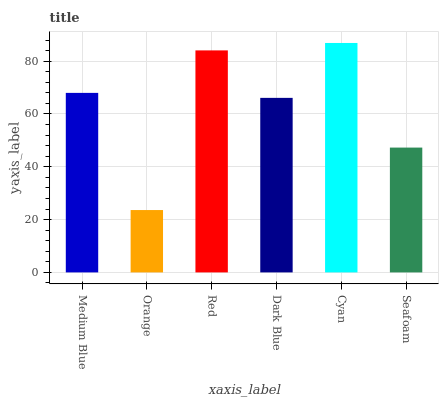Is Orange the minimum?
Answer yes or no. Yes. Is Cyan the maximum?
Answer yes or no. Yes. Is Red the minimum?
Answer yes or no. No. Is Red the maximum?
Answer yes or no. No. Is Red greater than Orange?
Answer yes or no. Yes. Is Orange less than Red?
Answer yes or no. Yes. Is Orange greater than Red?
Answer yes or no. No. Is Red less than Orange?
Answer yes or no. No. Is Medium Blue the high median?
Answer yes or no. Yes. Is Dark Blue the low median?
Answer yes or no. Yes. Is Dark Blue the high median?
Answer yes or no. No. Is Medium Blue the low median?
Answer yes or no. No. 